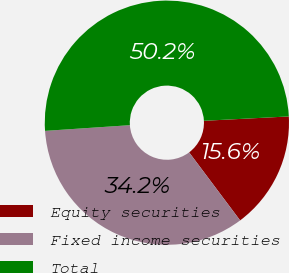<chart> <loc_0><loc_0><loc_500><loc_500><pie_chart><fcel>Equity securities<fcel>Fixed income securities<fcel>Total<nl><fcel>15.58%<fcel>34.17%<fcel>50.25%<nl></chart> 